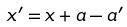<formula> <loc_0><loc_0><loc_500><loc_500>x ^ { \prime } = x + a - a ^ { \prime }</formula> 